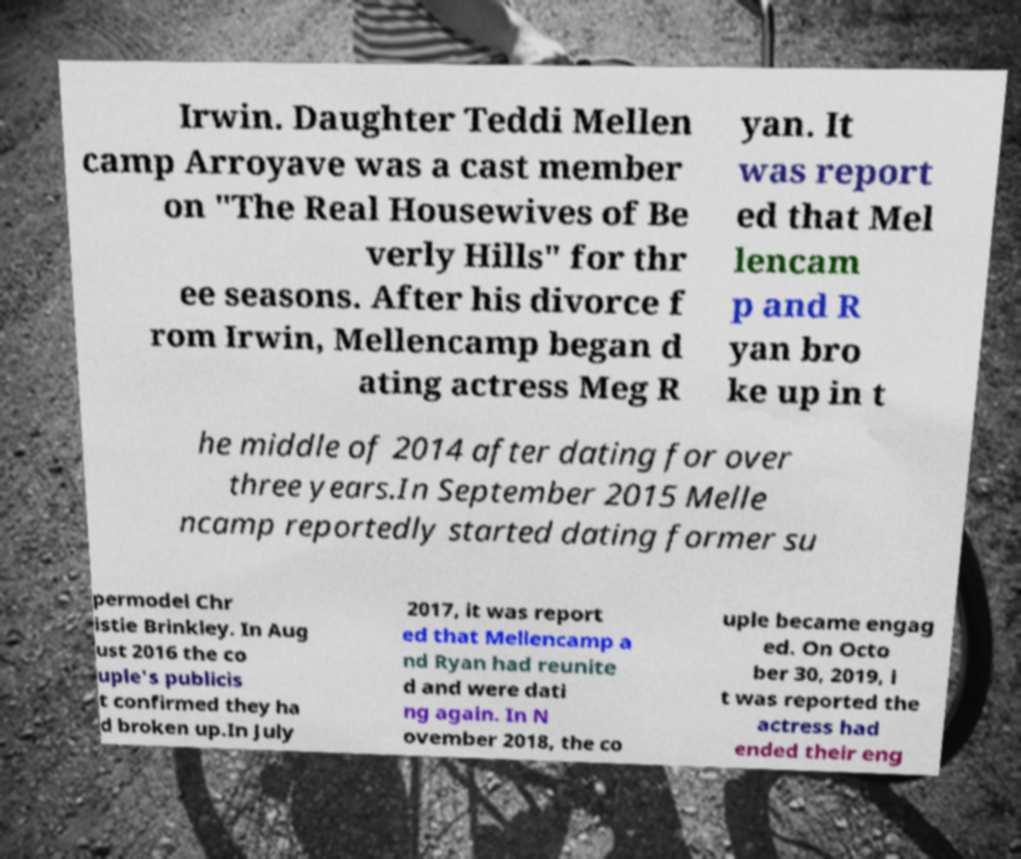I need the written content from this picture converted into text. Can you do that? Irwin. Daughter Teddi Mellen camp Arroyave was a cast member on "The Real Housewives of Be verly Hills" for thr ee seasons. After his divorce f rom Irwin, Mellencamp began d ating actress Meg R yan. It was report ed that Mel lencam p and R yan bro ke up in t he middle of 2014 after dating for over three years.In September 2015 Melle ncamp reportedly started dating former su permodel Chr istie Brinkley. In Aug ust 2016 the co uple's publicis t confirmed they ha d broken up.In July 2017, it was report ed that Mellencamp a nd Ryan had reunite d and were dati ng again. In N ovember 2018, the co uple became engag ed. On Octo ber 30, 2019, i t was reported the actress had ended their eng 